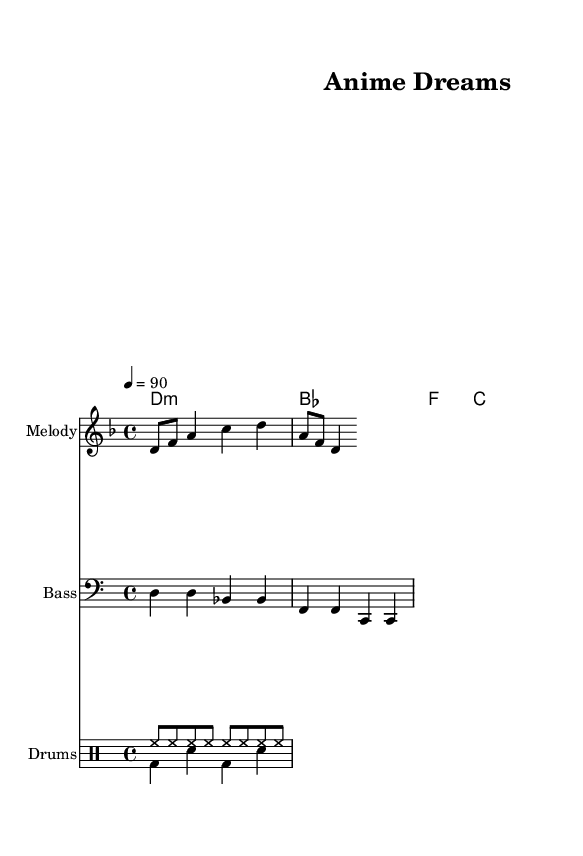What is the key signature of this music? The key signature is indicated at the beginning of the staff. Here, we see two flats, which corresponds to the key of D minor.
Answer: D minor What is the time signature of this music? The time signature is also located at the beginning of the staff. It shows a 4 over 4, meaning there are four beats in each measure and a quarter note gets one beat.
Answer: 4/4 What is the tempo marking for this piece? The tempo marking is provided as a number in beats per minute (BPM) located at the start. In this case, it reads "4 = 90", indicating the tempo is 90 beats per minute.
Answer: 90 How many measures are present in the melody? To find the number of measures, we count each measure barline in the melody section. There are four distinct measures, as indicated by the structure of the notes.
Answer: 4 What type of musical piece is this? The structure, chord progressions, and rhythms align with the characteristics of Rap music. The integration of melodic lines with a strong rhythmic foundation along with the usage of prominent drum patterns suggest this is a rap piece.
Answer: Rap Which instrument is indicated for the bass line? In the staff for the bass line, the clef is specifically set as "bass," which indicates that this part should be played on a bass instrument, typically a bass guitar or double bass.
Answer: Bass What rhythmic element is present in the drum pattern? The drum pattern indicates standard hip-hop rhythms featuring a kick drum (bd) and snare (sn), clearly showing syncopation as well as the use of hi-hat (hh) for added texture that is common in Rap music.
Answer: Hip-hop rhythms 